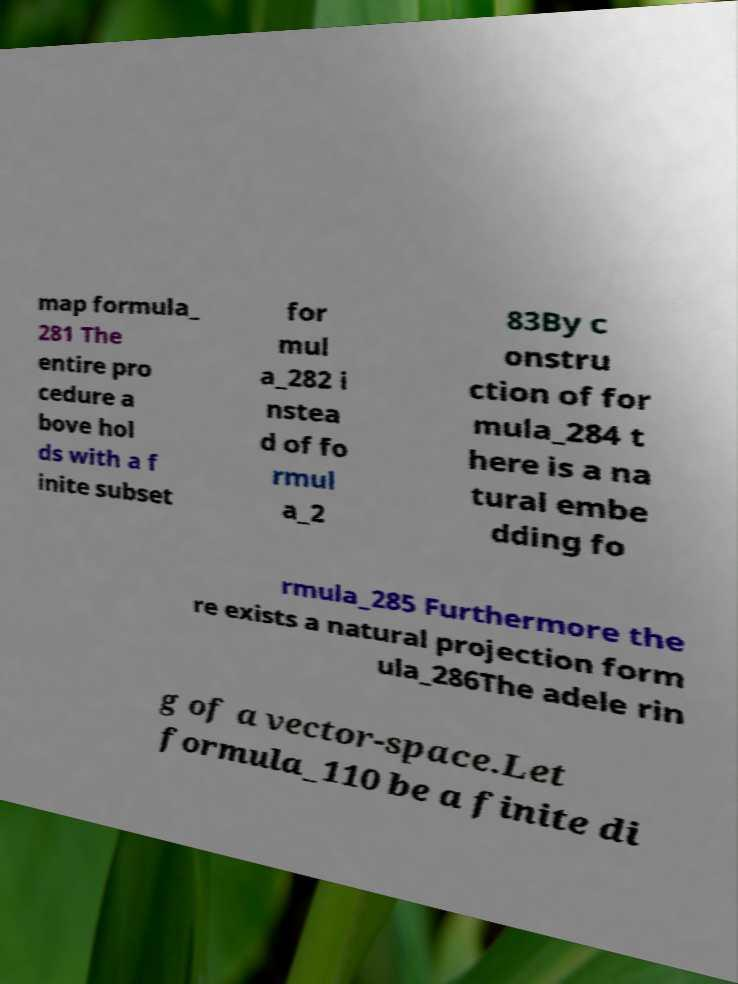What messages or text are displayed in this image? I need them in a readable, typed format. map formula_ 281 The entire pro cedure a bove hol ds with a f inite subset for mul a_282 i nstea d of fo rmul a_2 83By c onstru ction of for mula_284 t here is a na tural embe dding fo rmula_285 Furthermore the re exists a natural projection form ula_286The adele rin g of a vector-space.Let formula_110 be a finite di 